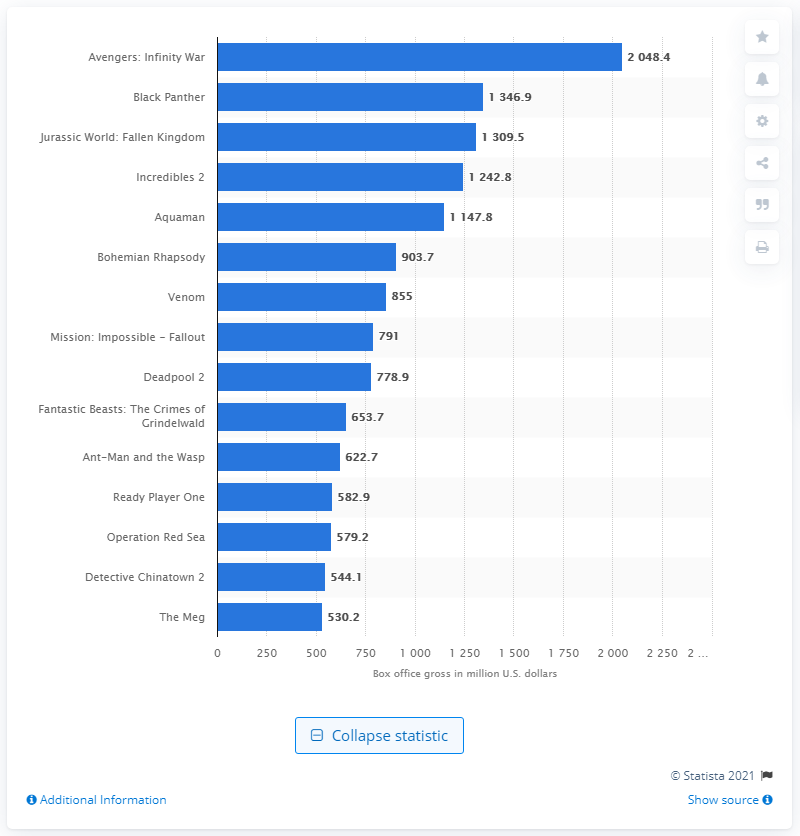Indicate a few pertinent items in this graphic. In 2018, the box office revenue of Black Panther was 1346.9 million dollars. The global box office revenue of Incredibles 2 was $1309.5 million. The box office revenue of Avengers: Infinity War was 2048.4. 